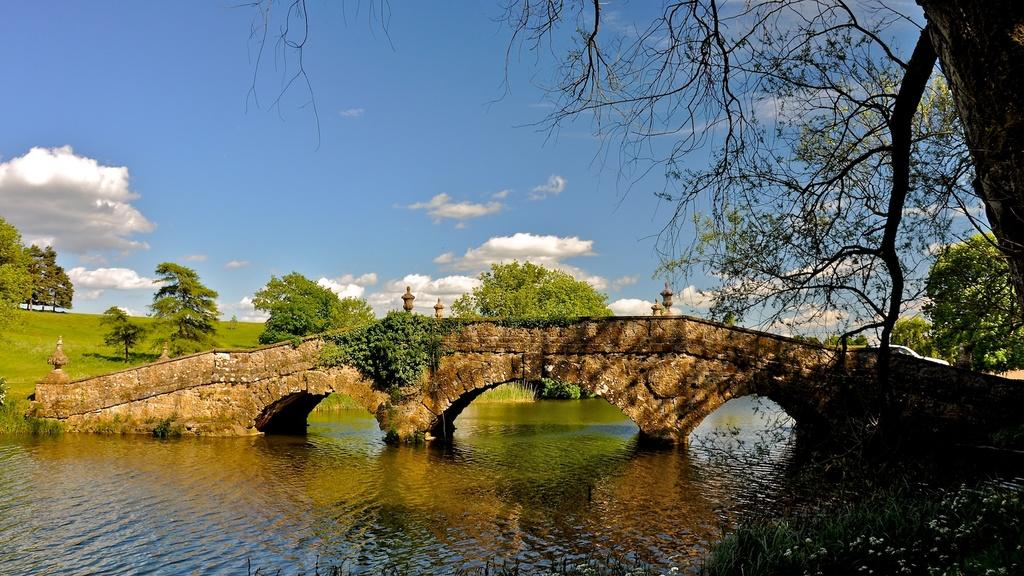What is in the foreground of the image? There is water in the foreground of the image. What can be seen on the right side of the foreground? There is a tree on the right side of the foreground. What structure is located in the middle of the image? There is a bridge in the middle of the image. What type of vegetation is visible in the background of the image? There are trees and grassland in the background of the image. What is visible in the sky in the background of the image? The sky is visible in the background of the image. What type of dirt is being used to make the coil in the image? There is no dirt or coil present in the image. What kind of meal is being prepared on the bridge in the image? There is no meal being prepared in the image; it features a bridge, water, trees, and grassland. 